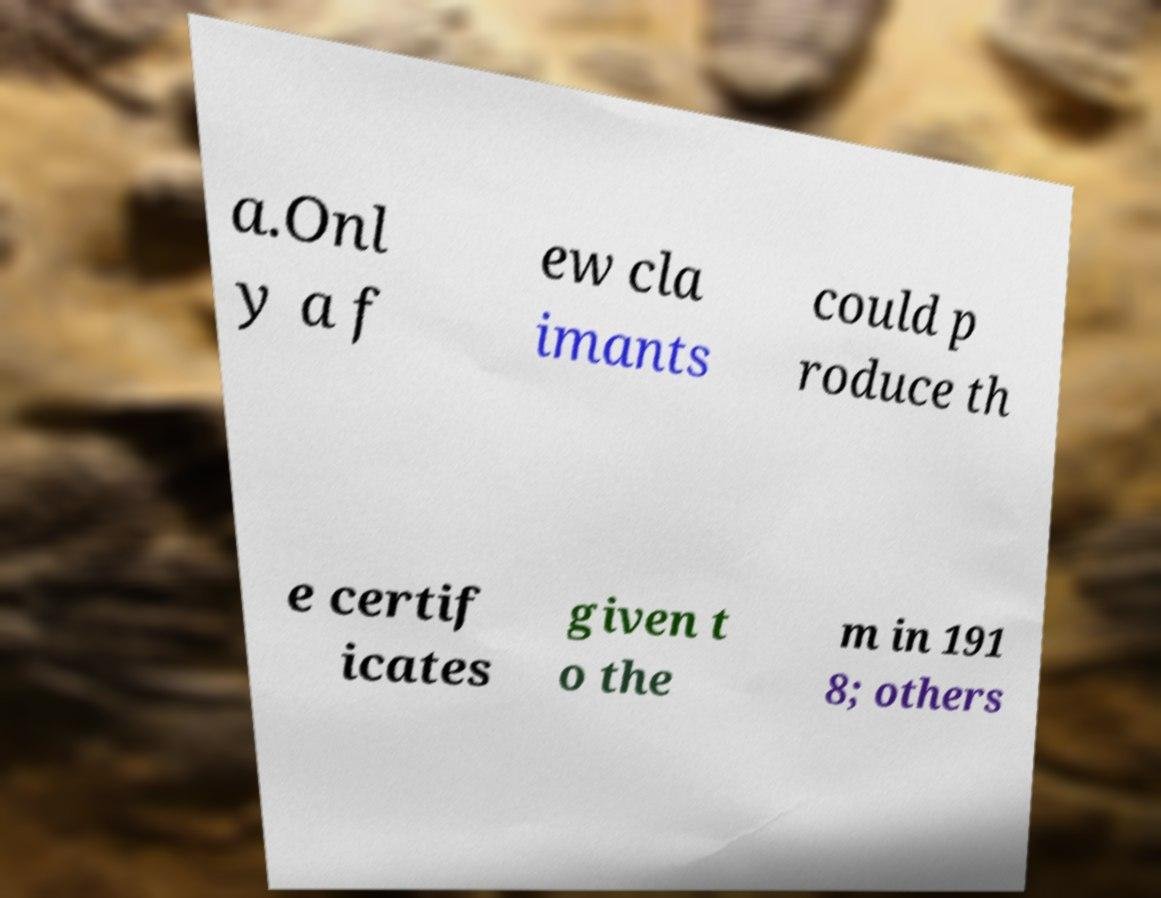What messages or text are displayed in this image? I need them in a readable, typed format. a.Onl y a f ew cla imants could p roduce th e certif icates given t o the m in 191 8; others 